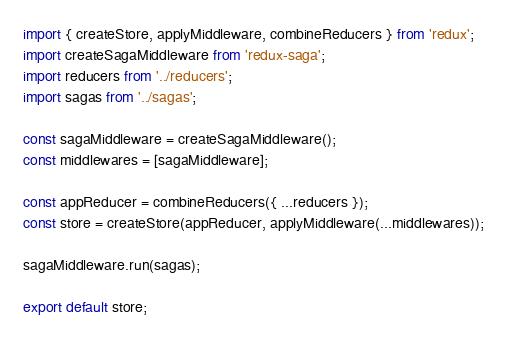<code> <loc_0><loc_0><loc_500><loc_500><_JavaScript_>import { createStore, applyMiddleware, combineReducers } from 'redux';
import createSagaMiddleware from 'redux-saga';
import reducers from '../reducers';
import sagas from '../sagas';

const sagaMiddleware = createSagaMiddleware();
const middlewares = [sagaMiddleware];

const appReducer = combineReducers({ ...reducers });
const store = createStore(appReducer, applyMiddleware(...middlewares));

sagaMiddleware.run(sagas);

export default store;</code> 